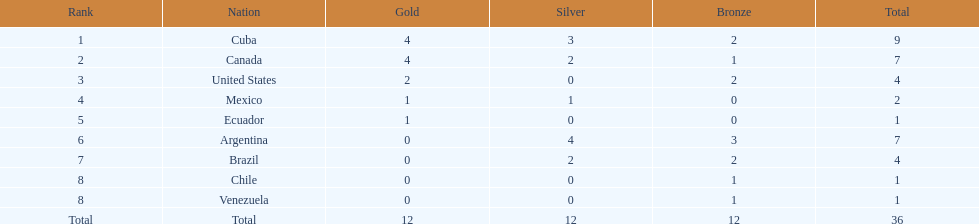Which nation won gold but did not win silver? United States. 